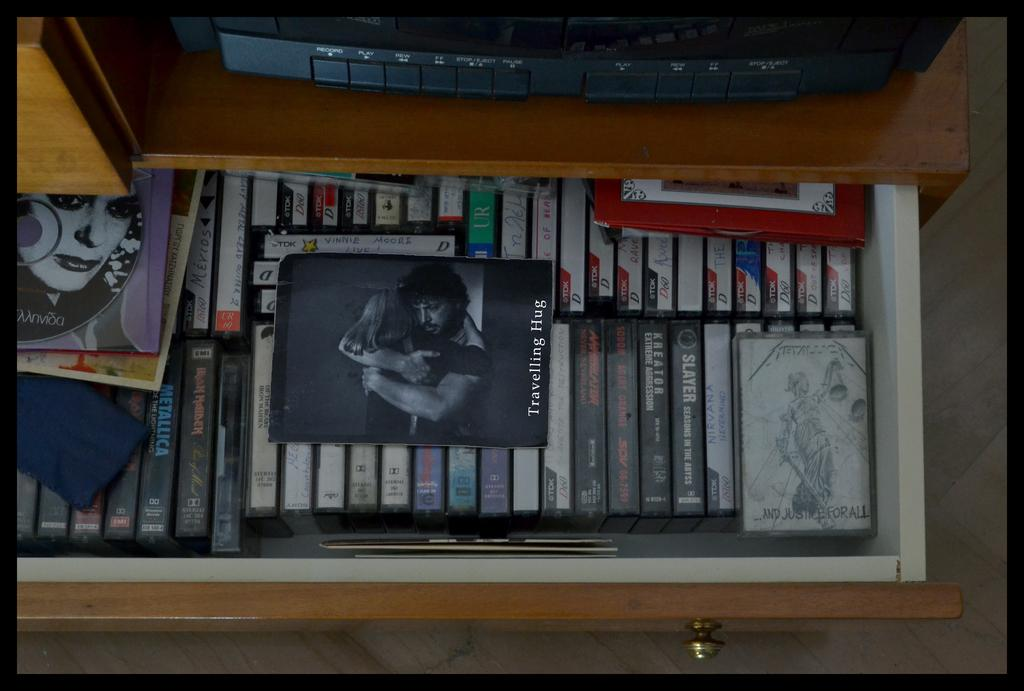<image>
Present a compact description of the photo's key features. A photograph titled Travelling Hug lays on a bunch of cassettes. 